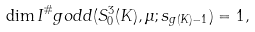Convert formula to latex. <formula><loc_0><loc_0><loc_500><loc_500>\dim I ^ { \# } _ { \ } g o d d ( S ^ { 3 } _ { 0 } ( K ) , \mu ; s _ { g ( K ) - 1 } ) = 1 ,</formula> 